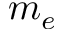Convert formula to latex. <formula><loc_0><loc_0><loc_500><loc_500>m _ { e }</formula> 